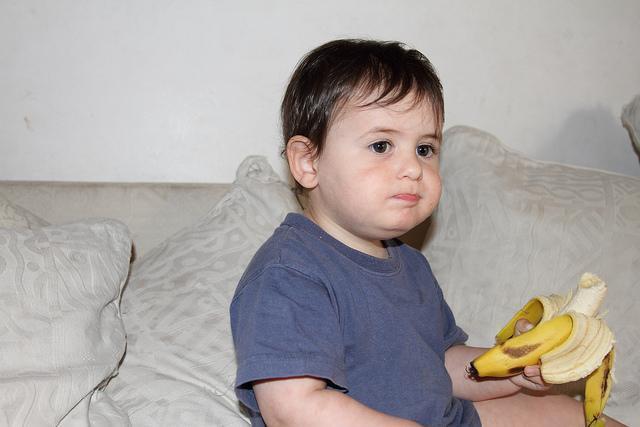How many children are eating?
Give a very brief answer. 1. 